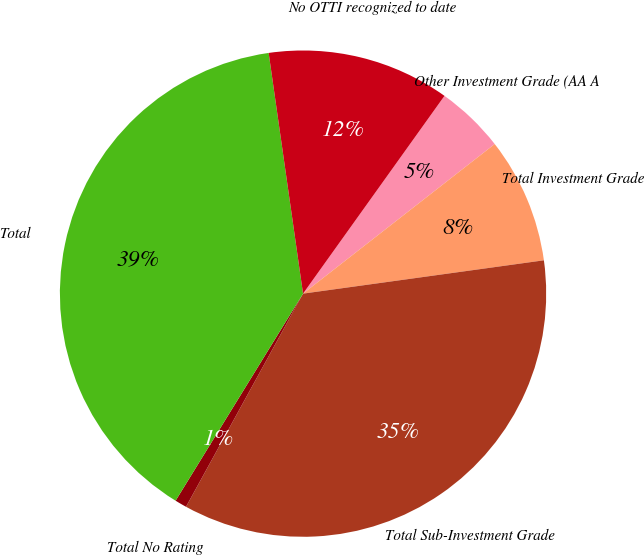Convert chart to OTSL. <chart><loc_0><loc_0><loc_500><loc_500><pie_chart><fcel>Other Investment Grade (AA A<fcel>Total Investment Grade<fcel>Total Sub-Investment Grade<fcel>Total No Rating<fcel>Total<fcel>No OTTI recognized to date<nl><fcel>4.57%<fcel>8.36%<fcel>35.18%<fcel>0.79%<fcel>38.96%<fcel>12.14%<nl></chart> 